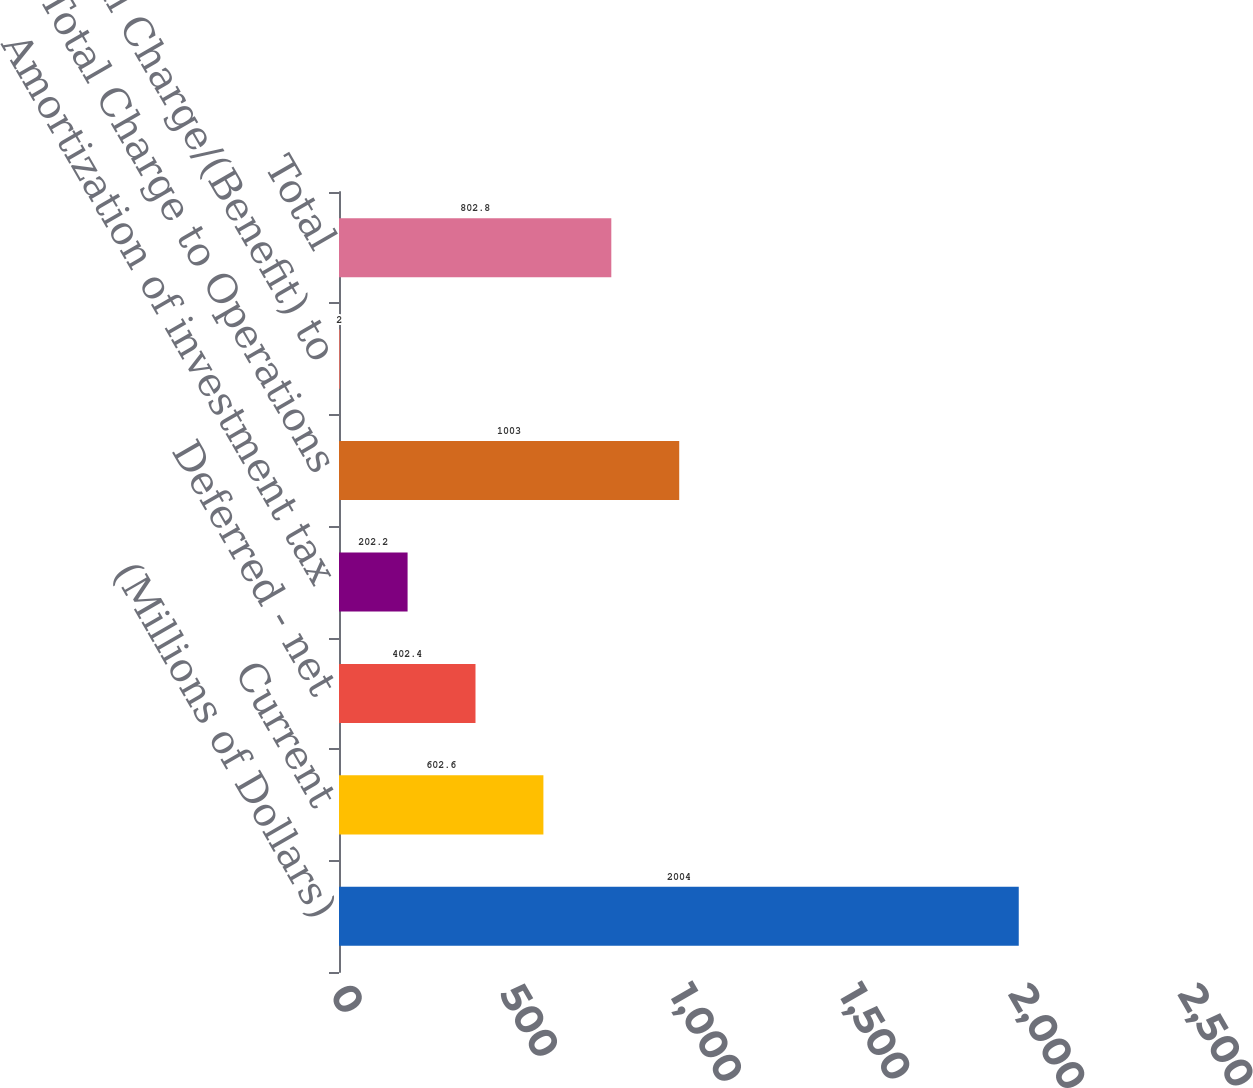Convert chart to OTSL. <chart><loc_0><loc_0><loc_500><loc_500><bar_chart><fcel>(Millions of Dollars)<fcel>Current<fcel>Deferred - net<fcel>Amortization of investment tax<fcel>Total Charge to Operations<fcel>Total Charge/(Benefit) to<fcel>Total<nl><fcel>2004<fcel>602.6<fcel>402.4<fcel>202.2<fcel>1003<fcel>2<fcel>802.8<nl></chart> 